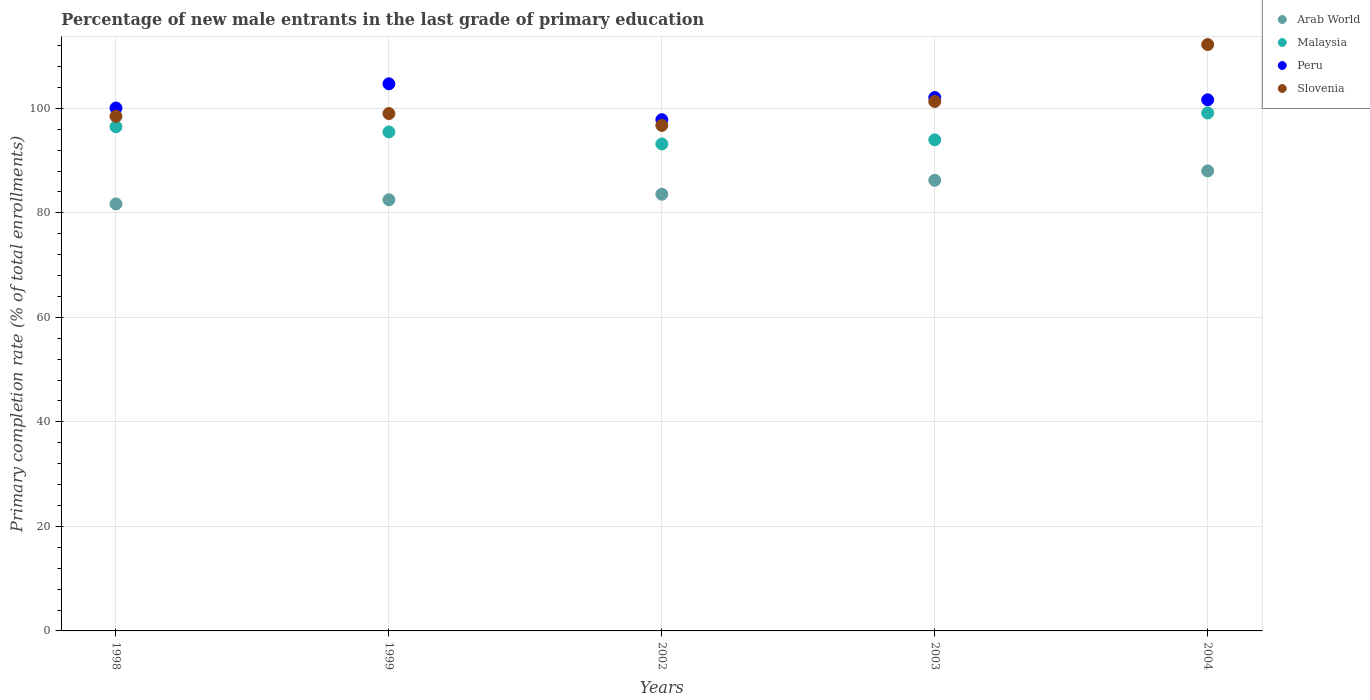How many different coloured dotlines are there?
Provide a succinct answer. 4. Is the number of dotlines equal to the number of legend labels?
Your answer should be compact. Yes. What is the percentage of new male entrants in Arab World in 2003?
Your answer should be very brief. 86.23. Across all years, what is the maximum percentage of new male entrants in Slovenia?
Offer a terse response. 112.21. Across all years, what is the minimum percentage of new male entrants in Arab World?
Your response must be concise. 81.72. In which year was the percentage of new male entrants in Malaysia minimum?
Your answer should be compact. 2002. What is the total percentage of new male entrants in Malaysia in the graph?
Keep it short and to the point. 478.25. What is the difference between the percentage of new male entrants in Malaysia in 1998 and that in 2003?
Your response must be concise. 2.5. What is the difference between the percentage of new male entrants in Malaysia in 1998 and the percentage of new male entrants in Peru in 1999?
Ensure brevity in your answer.  -8.22. What is the average percentage of new male entrants in Arab World per year?
Provide a short and direct response. 84.41. In the year 2004, what is the difference between the percentage of new male entrants in Arab World and percentage of new male entrants in Peru?
Offer a very short reply. -13.61. What is the ratio of the percentage of new male entrants in Malaysia in 1998 to that in 2002?
Offer a very short reply. 1.04. What is the difference between the highest and the second highest percentage of new male entrants in Malaysia?
Your answer should be very brief. 2.63. What is the difference between the highest and the lowest percentage of new male entrants in Arab World?
Keep it short and to the point. 6.31. In how many years, is the percentage of new male entrants in Malaysia greater than the average percentage of new male entrants in Malaysia taken over all years?
Give a very brief answer. 2. Is it the case that in every year, the sum of the percentage of new male entrants in Malaysia and percentage of new male entrants in Peru  is greater than the sum of percentage of new male entrants in Arab World and percentage of new male entrants in Slovenia?
Give a very brief answer. No. Is it the case that in every year, the sum of the percentage of new male entrants in Peru and percentage of new male entrants in Arab World  is greater than the percentage of new male entrants in Malaysia?
Ensure brevity in your answer.  Yes. Is the percentage of new male entrants in Malaysia strictly greater than the percentage of new male entrants in Slovenia over the years?
Ensure brevity in your answer.  No. What is the difference between two consecutive major ticks on the Y-axis?
Make the answer very short. 20. Are the values on the major ticks of Y-axis written in scientific E-notation?
Offer a very short reply. No. Does the graph contain any zero values?
Your answer should be very brief. No. Does the graph contain grids?
Offer a very short reply. Yes. How many legend labels are there?
Provide a succinct answer. 4. What is the title of the graph?
Keep it short and to the point. Percentage of new male entrants in the last grade of primary education. Does "India" appear as one of the legend labels in the graph?
Provide a short and direct response. No. What is the label or title of the Y-axis?
Keep it short and to the point. Primary completion rate (% of total enrollments). What is the Primary completion rate (% of total enrollments) in Arab World in 1998?
Keep it short and to the point. 81.72. What is the Primary completion rate (% of total enrollments) of Malaysia in 1998?
Offer a very short reply. 96.48. What is the Primary completion rate (% of total enrollments) of Peru in 1998?
Give a very brief answer. 100.07. What is the Primary completion rate (% of total enrollments) in Slovenia in 1998?
Ensure brevity in your answer.  98.48. What is the Primary completion rate (% of total enrollments) of Arab World in 1999?
Provide a short and direct response. 82.51. What is the Primary completion rate (% of total enrollments) in Malaysia in 1999?
Offer a very short reply. 95.49. What is the Primary completion rate (% of total enrollments) of Peru in 1999?
Offer a very short reply. 104.7. What is the Primary completion rate (% of total enrollments) of Slovenia in 1999?
Provide a succinct answer. 99.01. What is the Primary completion rate (% of total enrollments) of Arab World in 2002?
Make the answer very short. 83.57. What is the Primary completion rate (% of total enrollments) of Malaysia in 2002?
Provide a succinct answer. 93.19. What is the Primary completion rate (% of total enrollments) of Peru in 2002?
Give a very brief answer. 97.83. What is the Primary completion rate (% of total enrollments) in Slovenia in 2002?
Keep it short and to the point. 96.74. What is the Primary completion rate (% of total enrollments) of Arab World in 2003?
Provide a short and direct response. 86.23. What is the Primary completion rate (% of total enrollments) of Malaysia in 2003?
Ensure brevity in your answer.  93.98. What is the Primary completion rate (% of total enrollments) in Peru in 2003?
Your answer should be very brief. 102.07. What is the Primary completion rate (% of total enrollments) of Slovenia in 2003?
Provide a short and direct response. 101.32. What is the Primary completion rate (% of total enrollments) of Arab World in 2004?
Provide a succinct answer. 88.03. What is the Primary completion rate (% of total enrollments) in Malaysia in 2004?
Provide a succinct answer. 99.11. What is the Primary completion rate (% of total enrollments) of Peru in 2004?
Offer a terse response. 101.64. What is the Primary completion rate (% of total enrollments) in Slovenia in 2004?
Provide a succinct answer. 112.21. Across all years, what is the maximum Primary completion rate (% of total enrollments) of Arab World?
Keep it short and to the point. 88.03. Across all years, what is the maximum Primary completion rate (% of total enrollments) in Malaysia?
Make the answer very short. 99.11. Across all years, what is the maximum Primary completion rate (% of total enrollments) in Peru?
Provide a succinct answer. 104.7. Across all years, what is the maximum Primary completion rate (% of total enrollments) of Slovenia?
Your answer should be compact. 112.21. Across all years, what is the minimum Primary completion rate (% of total enrollments) of Arab World?
Offer a terse response. 81.72. Across all years, what is the minimum Primary completion rate (% of total enrollments) of Malaysia?
Your response must be concise. 93.19. Across all years, what is the minimum Primary completion rate (% of total enrollments) in Peru?
Offer a very short reply. 97.83. Across all years, what is the minimum Primary completion rate (% of total enrollments) of Slovenia?
Offer a terse response. 96.74. What is the total Primary completion rate (% of total enrollments) in Arab World in the graph?
Provide a succinct answer. 422.05. What is the total Primary completion rate (% of total enrollments) in Malaysia in the graph?
Your answer should be compact. 478.25. What is the total Primary completion rate (% of total enrollments) of Peru in the graph?
Offer a terse response. 506.32. What is the total Primary completion rate (% of total enrollments) of Slovenia in the graph?
Give a very brief answer. 507.76. What is the difference between the Primary completion rate (% of total enrollments) of Arab World in 1998 and that in 1999?
Your answer should be compact. -0.79. What is the difference between the Primary completion rate (% of total enrollments) in Peru in 1998 and that in 1999?
Your answer should be compact. -4.63. What is the difference between the Primary completion rate (% of total enrollments) in Slovenia in 1998 and that in 1999?
Make the answer very short. -0.53. What is the difference between the Primary completion rate (% of total enrollments) in Arab World in 1998 and that in 2002?
Provide a short and direct response. -1.85. What is the difference between the Primary completion rate (% of total enrollments) in Malaysia in 1998 and that in 2002?
Your answer should be compact. 3.29. What is the difference between the Primary completion rate (% of total enrollments) of Peru in 1998 and that in 2002?
Give a very brief answer. 2.24. What is the difference between the Primary completion rate (% of total enrollments) in Slovenia in 1998 and that in 2002?
Provide a short and direct response. 1.73. What is the difference between the Primary completion rate (% of total enrollments) in Arab World in 1998 and that in 2003?
Provide a short and direct response. -4.52. What is the difference between the Primary completion rate (% of total enrollments) of Malaysia in 1998 and that in 2003?
Offer a very short reply. 2.5. What is the difference between the Primary completion rate (% of total enrollments) in Peru in 1998 and that in 2003?
Provide a succinct answer. -2. What is the difference between the Primary completion rate (% of total enrollments) of Slovenia in 1998 and that in 2003?
Give a very brief answer. -2.84. What is the difference between the Primary completion rate (% of total enrollments) of Arab World in 1998 and that in 2004?
Keep it short and to the point. -6.31. What is the difference between the Primary completion rate (% of total enrollments) in Malaysia in 1998 and that in 2004?
Your answer should be very brief. -2.63. What is the difference between the Primary completion rate (% of total enrollments) of Peru in 1998 and that in 2004?
Ensure brevity in your answer.  -1.57. What is the difference between the Primary completion rate (% of total enrollments) of Slovenia in 1998 and that in 2004?
Your answer should be compact. -13.74. What is the difference between the Primary completion rate (% of total enrollments) of Arab World in 1999 and that in 2002?
Offer a very short reply. -1.06. What is the difference between the Primary completion rate (% of total enrollments) of Malaysia in 1999 and that in 2002?
Give a very brief answer. 2.3. What is the difference between the Primary completion rate (% of total enrollments) in Peru in 1999 and that in 2002?
Offer a very short reply. 6.87. What is the difference between the Primary completion rate (% of total enrollments) in Slovenia in 1999 and that in 2002?
Provide a short and direct response. 2.27. What is the difference between the Primary completion rate (% of total enrollments) in Arab World in 1999 and that in 2003?
Make the answer very short. -3.73. What is the difference between the Primary completion rate (% of total enrollments) of Malaysia in 1999 and that in 2003?
Give a very brief answer. 1.5. What is the difference between the Primary completion rate (% of total enrollments) of Peru in 1999 and that in 2003?
Your answer should be compact. 2.62. What is the difference between the Primary completion rate (% of total enrollments) of Slovenia in 1999 and that in 2003?
Offer a terse response. -2.31. What is the difference between the Primary completion rate (% of total enrollments) of Arab World in 1999 and that in 2004?
Make the answer very short. -5.52. What is the difference between the Primary completion rate (% of total enrollments) of Malaysia in 1999 and that in 2004?
Your response must be concise. -3.62. What is the difference between the Primary completion rate (% of total enrollments) of Peru in 1999 and that in 2004?
Give a very brief answer. 3.06. What is the difference between the Primary completion rate (% of total enrollments) in Slovenia in 1999 and that in 2004?
Offer a very short reply. -13.2. What is the difference between the Primary completion rate (% of total enrollments) of Arab World in 2002 and that in 2003?
Your response must be concise. -2.67. What is the difference between the Primary completion rate (% of total enrollments) of Malaysia in 2002 and that in 2003?
Make the answer very short. -0.79. What is the difference between the Primary completion rate (% of total enrollments) in Peru in 2002 and that in 2003?
Give a very brief answer. -4.24. What is the difference between the Primary completion rate (% of total enrollments) of Slovenia in 2002 and that in 2003?
Your answer should be very brief. -4.58. What is the difference between the Primary completion rate (% of total enrollments) in Arab World in 2002 and that in 2004?
Provide a short and direct response. -4.46. What is the difference between the Primary completion rate (% of total enrollments) of Malaysia in 2002 and that in 2004?
Your answer should be compact. -5.92. What is the difference between the Primary completion rate (% of total enrollments) in Peru in 2002 and that in 2004?
Provide a short and direct response. -3.81. What is the difference between the Primary completion rate (% of total enrollments) in Slovenia in 2002 and that in 2004?
Your answer should be compact. -15.47. What is the difference between the Primary completion rate (% of total enrollments) in Arab World in 2003 and that in 2004?
Your answer should be very brief. -1.8. What is the difference between the Primary completion rate (% of total enrollments) in Malaysia in 2003 and that in 2004?
Your answer should be compact. -5.13. What is the difference between the Primary completion rate (% of total enrollments) in Peru in 2003 and that in 2004?
Provide a short and direct response. 0.44. What is the difference between the Primary completion rate (% of total enrollments) in Slovenia in 2003 and that in 2004?
Provide a succinct answer. -10.89. What is the difference between the Primary completion rate (% of total enrollments) in Arab World in 1998 and the Primary completion rate (% of total enrollments) in Malaysia in 1999?
Your answer should be compact. -13.77. What is the difference between the Primary completion rate (% of total enrollments) in Arab World in 1998 and the Primary completion rate (% of total enrollments) in Peru in 1999?
Offer a very short reply. -22.98. What is the difference between the Primary completion rate (% of total enrollments) in Arab World in 1998 and the Primary completion rate (% of total enrollments) in Slovenia in 1999?
Give a very brief answer. -17.29. What is the difference between the Primary completion rate (% of total enrollments) in Malaysia in 1998 and the Primary completion rate (% of total enrollments) in Peru in 1999?
Make the answer very short. -8.22. What is the difference between the Primary completion rate (% of total enrollments) in Malaysia in 1998 and the Primary completion rate (% of total enrollments) in Slovenia in 1999?
Provide a short and direct response. -2.53. What is the difference between the Primary completion rate (% of total enrollments) in Peru in 1998 and the Primary completion rate (% of total enrollments) in Slovenia in 1999?
Ensure brevity in your answer.  1.06. What is the difference between the Primary completion rate (% of total enrollments) in Arab World in 1998 and the Primary completion rate (% of total enrollments) in Malaysia in 2002?
Provide a succinct answer. -11.47. What is the difference between the Primary completion rate (% of total enrollments) of Arab World in 1998 and the Primary completion rate (% of total enrollments) of Peru in 2002?
Give a very brief answer. -16.12. What is the difference between the Primary completion rate (% of total enrollments) of Arab World in 1998 and the Primary completion rate (% of total enrollments) of Slovenia in 2002?
Offer a very short reply. -15.03. What is the difference between the Primary completion rate (% of total enrollments) of Malaysia in 1998 and the Primary completion rate (% of total enrollments) of Peru in 2002?
Offer a very short reply. -1.35. What is the difference between the Primary completion rate (% of total enrollments) of Malaysia in 1998 and the Primary completion rate (% of total enrollments) of Slovenia in 2002?
Make the answer very short. -0.26. What is the difference between the Primary completion rate (% of total enrollments) in Peru in 1998 and the Primary completion rate (% of total enrollments) in Slovenia in 2002?
Offer a very short reply. 3.33. What is the difference between the Primary completion rate (% of total enrollments) in Arab World in 1998 and the Primary completion rate (% of total enrollments) in Malaysia in 2003?
Give a very brief answer. -12.27. What is the difference between the Primary completion rate (% of total enrollments) of Arab World in 1998 and the Primary completion rate (% of total enrollments) of Peru in 2003?
Provide a short and direct response. -20.36. What is the difference between the Primary completion rate (% of total enrollments) of Arab World in 1998 and the Primary completion rate (% of total enrollments) of Slovenia in 2003?
Provide a succinct answer. -19.6. What is the difference between the Primary completion rate (% of total enrollments) of Malaysia in 1998 and the Primary completion rate (% of total enrollments) of Peru in 2003?
Ensure brevity in your answer.  -5.6. What is the difference between the Primary completion rate (% of total enrollments) of Malaysia in 1998 and the Primary completion rate (% of total enrollments) of Slovenia in 2003?
Offer a terse response. -4.84. What is the difference between the Primary completion rate (% of total enrollments) of Peru in 1998 and the Primary completion rate (% of total enrollments) of Slovenia in 2003?
Your answer should be very brief. -1.25. What is the difference between the Primary completion rate (% of total enrollments) of Arab World in 1998 and the Primary completion rate (% of total enrollments) of Malaysia in 2004?
Keep it short and to the point. -17.4. What is the difference between the Primary completion rate (% of total enrollments) of Arab World in 1998 and the Primary completion rate (% of total enrollments) of Peru in 2004?
Your response must be concise. -19.92. What is the difference between the Primary completion rate (% of total enrollments) in Arab World in 1998 and the Primary completion rate (% of total enrollments) in Slovenia in 2004?
Offer a very short reply. -30.5. What is the difference between the Primary completion rate (% of total enrollments) in Malaysia in 1998 and the Primary completion rate (% of total enrollments) in Peru in 2004?
Ensure brevity in your answer.  -5.16. What is the difference between the Primary completion rate (% of total enrollments) in Malaysia in 1998 and the Primary completion rate (% of total enrollments) in Slovenia in 2004?
Your response must be concise. -15.73. What is the difference between the Primary completion rate (% of total enrollments) in Peru in 1998 and the Primary completion rate (% of total enrollments) in Slovenia in 2004?
Ensure brevity in your answer.  -12.14. What is the difference between the Primary completion rate (% of total enrollments) in Arab World in 1999 and the Primary completion rate (% of total enrollments) in Malaysia in 2002?
Offer a very short reply. -10.68. What is the difference between the Primary completion rate (% of total enrollments) of Arab World in 1999 and the Primary completion rate (% of total enrollments) of Peru in 2002?
Offer a terse response. -15.33. What is the difference between the Primary completion rate (% of total enrollments) of Arab World in 1999 and the Primary completion rate (% of total enrollments) of Slovenia in 2002?
Make the answer very short. -14.24. What is the difference between the Primary completion rate (% of total enrollments) in Malaysia in 1999 and the Primary completion rate (% of total enrollments) in Peru in 2002?
Provide a short and direct response. -2.34. What is the difference between the Primary completion rate (% of total enrollments) in Malaysia in 1999 and the Primary completion rate (% of total enrollments) in Slovenia in 2002?
Offer a terse response. -1.25. What is the difference between the Primary completion rate (% of total enrollments) of Peru in 1999 and the Primary completion rate (% of total enrollments) of Slovenia in 2002?
Give a very brief answer. 7.96. What is the difference between the Primary completion rate (% of total enrollments) in Arab World in 1999 and the Primary completion rate (% of total enrollments) in Malaysia in 2003?
Offer a very short reply. -11.48. What is the difference between the Primary completion rate (% of total enrollments) of Arab World in 1999 and the Primary completion rate (% of total enrollments) of Peru in 2003?
Keep it short and to the point. -19.57. What is the difference between the Primary completion rate (% of total enrollments) in Arab World in 1999 and the Primary completion rate (% of total enrollments) in Slovenia in 2003?
Make the answer very short. -18.81. What is the difference between the Primary completion rate (% of total enrollments) in Malaysia in 1999 and the Primary completion rate (% of total enrollments) in Peru in 2003?
Provide a succinct answer. -6.59. What is the difference between the Primary completion rate (% of total enrollments) in Malaysia in 1999 and the Primary completion rate (% of total enrollments) in Slovenia in 2003?
Provide a short and direct response. -5.83. What is the difference between the Primary completion rate (% of total enrollments) in Peru in 1999 and the Primary completion rate (% of total enrollments) in Slovenia in 2003?
Provide a short and direct response. 3.38. What is the difference between the Primary completion rate (% of total enrollments) in Arab World in 1999 and the Primary completion rate (% of total enrollments) in Malaysia in 2004?
Provide a short and direct response. -16.61. What is the difference between the Primary completion rate (% of total enrollments) of Arab World in 1999 and the Primary completion rate (% of total enrollments) of Peru in 2004?
Your answer should be very brief. -19.13. What is the difference between the Primary completion rate (% of total enrollments) in Arab World in 1999 and the Primary completion rate (% of total enrollments) in Slovenia in 2004?
Your answer should be compact. -29.71. What is the difference between the Primary completion rate (% of total enrollments) of Malaysia in 1999 and the Primary completion rate (% of total enrollments) of Peru in 2004?
Keep it short and to the point. -6.15. What is the difference between the Primary completion rate (% of total enrollments) in Malaysia in 1999 and the Primary completion rate (% of total enrollments) in Slovenia in 2004?
Offer a very short reply. -16.72. What is the difference between the Primary completion rate (% of total enrollments) in Peru in 1999 and the Primary completion rate (% of total enrollments) in Slovenia in 2004?
Your response must be concise. -7.51. What is the difference between the Primary completion rate (% of total enrollments) of Arab World in 2002 and the Primary completion rate (% of total enrollments) of Malaysia in 2003?
Offer a very short reply. -10.42. What is the difference between the Primary completion rate (% of total enrollments) in Arab World in 2002 and the Primary completion rate (% of total enrollments) in Peru in 2003?
Your response must be concise. -18.51. What is the difference between the Primary completion rate (% of total enrollments) of Arab World in 2002 and the Primary completion rate (% of total enrollments) of Slovenia in 2003?
Offer a very short reply. -17.75. What is the difference between the Primary completion rate (% of total enrollments) of Malaysia in 2002 and the Primary completion rate (% of total enrollments) of Peru in 2003?
Provide a succinct answer. -8.89. What is the difference between the Primary completion rate (% of total enrollments) in Malaysia in 2002 and the Primary completion rate (% of total enrollments) in Slovenia in 2003?
Your response must be concise. -8.13. What is the difference between the Primary completion rate (% of total enrollments) of Peru in 2002 and the Primary completion rate (% of total enrollments) of Slovenia in 2003?
Offer a very short reply. -3.49. What is the difference between the Primary completion rate (% of total enrollments) of Arab World in 2002 and the Primary completion rate (% of total enrollments) of Malaysia in 2004?
Make the answer very short. -15.55. What is the difference between the Primary completion rate (% of total enrollments) of Arab World in 2002 and the Primary completion rate (% of total enrollments) of Peru in 2004?
Offer a very short reply. -18.07. What is the difference between the Primary completion rate (% of total enrollments) of Arab World in 2002 and the Primary completion rate (% of total enrollments) of Slovenia in 2004?
Keep it short and to the point. -28.65. What is the difference between the Primary completion rate (% of total enrollments) in Malaysia in 2002 and the Primary completion rate (% of total enrollments) in Peru in 2004?
Keep it short and to the point. -8.45. What is the difference between the Primary completion rate (% of total enrollments) of Malaysia in 2002 and the Primary completion rate (% of total enrollments) of Slovenia in 2004?
Offer a terse response. -19.02. What is the difference between the Primary completion rate (% of total enrollments) in Peru in 2002 and the Primary completion rate (% of total enrollments) in Slovenia in 2004?
Your answer should be compact. -14.38. What is the difference between the Primary completion rate (% of total enrollments) of Arab World in 2003 and the Primary completion rate (% of total enrollments) of Malaysia in 2004?
Your answer should be very brief. -12.88. What is the difference between the Primary completion rate (% of total enrollments) in Arab World in 2003 and the Primary completion rate (% of total enrollments) in Peru in 2004?
Give a very brief answer. -15.41. What is the difference between the Primary completion rate (% of total enrollments) in Arab World in 2003 and the Primary completion rate (% of total enrollments) in Slovenia in 2004?
Offer a very short reply. -25.98. What is the difference between the Primary completion rate (% of total enrollments) of Malaysia in 2003 and the Primary completion rate (% of total enrollments) of Peru in 2004?
Make the answer very short. -7.66. What is the difference between the Primary completion rate (% of total enrollments) in Malaysia in 2003 and the Primary completion rate (% of total enrollments) in Slovenia in 2004?
Your answer should be very brief. -18.23. What is the difference between the Primary completion rate (% of total enrollments) in Peru in 2003 and the Primary completion rate (% of total enrollments) in Slovenia in 2004?
Give a very brief answer. -10.14. What is the average Primary completion rate (% of total enrollments) of Arab World per year?
Offer a terse response. 84.41. What is the average Primary completion rate (% of total enrollments) of Malaysia per year?
Offer a terse response. 95.65. What is the average Primary completion rate (% of total enrollments) of Peru per year?
Your answer should be very brief. 101.26. What is the average Primary completion rate (% of total enrollments) in Slovenia per year?
Provide a succinct answer. 101.55. In the year 1998, what is the difference between the Primary completion rate (% of total enrollments) of Arab World and Primary completion rate (% of total enrollments) of Malaysia?
Offer a very short reply. -14.76. In the year 1998, what is the difference between the Primary completion rate (% of total enrollments) in Arab World and Primary completion rate (% of total enrollments) in Peru?
Offer a terse response. -18.36. In the year 1998, what is the difference between the Primary completion rate (% of total enrollments) in Arab World and Primary completion rate (% of total enrollments) in Slovenia?
Provide a succinct answer. -16.76. In the year 1998, what is the difference between the Primary completion rate (% of total enrollments) in Malaysia and Primary completion rate (% of total enrollments) in Peru?
Provide a succinct answer. -3.59. In the year 1998, what is the difference between the Primary completion rate (% of total enrollments) of Malaysia and Primary completion rate (% of total enrollments) of Slovenia?
Your answer should be compact. -2. In the year 1998, what is the difference between the Primary completion rate (% of total enrollments) of Peru and Primary completion rate (% of total enrollments) of Slovenia?
Keep it short and to the point. 1.6. In the year 1999, what is the difference between the Primary completion rate (% of total enrollments) in Arab World and Primary completion rate (% of total enrollments) in Malaysia?
Ensure brevity in your answer.  -12.98. In the year 1999, what is the difference between the Primary completion rate (% of total enrollments) of Arab World and Primary completion rate (% of total enrollments) of Peru?
Offer a very short reply. -22.19. In the year 1999, what is the difference between the Primary completion rate (% of total enrollments) in Arab World and Primary completion rate (% of total enrollments) in Slovenia?
Give a very brief answer. -16.5. In the year 1999, what is the difference between the Primary completion rate (% of total enrollments) in Malaysia and Primary completion rate (% of total enrollments) in Peru?
Provide a short and direct response. -9.21. In the year 1999, what is the difference between the Primary completion rate (% of total enrollments) of Malaysia and Primary completion rate (% of total enrollments) of Slovenia?
Give a very brief answer. -3.52. In the year 1999, what is the difference between the Primary completion rate (% of total enrollments) in Peru and Primary completion rate (% of total enrollments) in Slovenia?
Ensure brevity in your answer.  5.69. In the year 2002, what is the difference between the Primary completion rate (% of total enrollments) of Arab World and Primary completion rate (% of total enrollments) of Malaysia?
Give a very brief answer. -9.62. In the year 2002, what is the difference between the Primary completion rate (% of total enrollments) in Arab World and Primary completion rate (% of total enrollments) in Peru?
Make the answer very short. -14.27. In the year 2002, what is the difference between the Primary completion rate (% of total enrollments) of Arab World and Primary completion rate (% of total enrollments) of Slovenia?
Make the answer very short. -13.18. In the year 2002, what is the difference between the Primary completion rate (% of total enrollments) in Malaysia and Primary completion rate (% of total enrollments) in Peru?
Make the answer very short. -4.64. In the year 2002, what is the difference between the Primary completion rate (% of total enrollments) of Malaysia and Primary completion rate (% of total enrollments) of Slovenia?
Your answer should be compact. -3.55. In the year 2002, what is the difference between the Primary completion rate (% of total enrollments) in Peru and Primary completion rate (% of total enrollments) in Slovenia?
Your answer should be very brief. 1.09. In the year 2003, what is the difference between the Primary completion rate (% of total enrollments) in Arab World and Primary completion rate (% of total enrollments) in Malaysia?
Make the answer very short. -7.75. In the year 2003, what is the difference between the Primary completion rate (% of total enrollments) in Arab World and Primary completion rate (% of total enrollments) in Peru?
Ensure brevity in your answer.  -15.84. In the year 2003, what is the difference between the Primary completion rate (% of total enrollments) in Arab World and Primary completion rate (% of total enrollments) in Slovenia?
Ensure brevity in your answer.  -15.09. In the year 2003, what is the difference between the Primary completion rate (% of total enrollments) in Malaysia and Primary completion rate (% of total enrollments) in Peru?
Your response must be concise. -8.09. In the year 2003, what is the difference between the Primary completion rate (% of total enrollments) in Malaysia and Primary completion rate (% of total enrollments) in Slovenia?
Your answer should be compact. -7.34. In the year 2003, what is the difference between the Primary completion rate (% of total enrollments) of Peru and Primary completion rate (% of total enrollments) of Slovenia?
Provide a short and direct response. 0.76. In the year 2004, what is the difference between the Primary completion rate (% of total enrollments) of Arab World and Primary completion rate (% of total enrollments) of Malaysia?
Ensure brevity in your answer.  -11.08. In the year 2004, what is the difference between the Primary completion rate (% of total enrollments) in Arab World and Primary completion rate (% of total enrollments) in Peru?
Offer a very short reply. -13.61. In the year 2004, what is the difference between the Primary completion rate (% of total enrollments) of Arab World and Primary completion rate (% of total enrollments) of Slovenia?
Offer a terse response. -24.18. In the year 2004, what is the difference between the Primary completion rate (% of total enrollments) in Malaysia and Primary completion rate (% of total enrollments) in Peru?
Your response must be concise. -2.53. In the year 2004, what is the difference between the Primary completion rate (% of total enrollments) of Malaysia and Primary completion rate (% of total enrollments) of Slovenia?
Make the answer very short. -13.1. In the year 2004, what is the difference between the Primary completion rate (% of total enrollments) of Peru and Primary completion rate (% of total enrollments) of Slovenia?
Keep it short and to the point. -10.57. What is the ratio of the Primary completion rate (% of total enrollments) in Malaysia in 1998 to that in 1999?
Your answer should be very brief. 1.01. What is the ratio of the Primary completion rate (% of total enrollments) in Peru in 1998 to that in 1999?
Your answer should be compact. 0.96. What is the ratio of the Primary completion rate (% of total enrollments) of Arab World in 1998 to that in 2002?
Offer a terse response. 0.98. What is the ratio of the Primary completion rate (% of total enrollments) of Malaysia in 1998 to that in 2002?
Give a very brief answer. 1.04. What is the ratio of the Primary completion rate (% of total enrollments) in Peru in 1998 to that in 2002?
Offer a terse response. 1.02. What is the ratio of the Primary completion rate (% of total enrollments) in Slovenia in 1998 to that in 2002?
Provide a succinct answer. 1.02. What is the ratio of the Primary completion rate (% of total enrollments) of Arab World in 1998 to that in 2003?
Give a very brief answer. 0.95. What is the ratio of the Primary completion rate (% of total enrollments) in Malaysia in 1998 to that in 2003?
Provide a short and direct response. 1.03. What is the ratio of the Primary completion rate (% of total enrollments) of Peru in 1998 to that in 2003?
Your response must be concise. 0.98. What is the ratio of the Primary completion rate (% of total enrollments) of Slovenia in 1998 to that in 2003?
Offer a very short reply. 0.97. What is the ratio of the Primary completion rate (% of total enrollments) of Arab World in 1998 to that in 2004?
Offer a terse response. 0.93. What is the ratio of the Primary completion rate (% of total enrollments) in Malaysia in 1998 to that in 2004?
Provide a succinct answer. 0.97. What is the ratio of the Primary completion rate (% of total enrollments) in Peru in 1998 to that in 2004?
Keep it short and to the point. 0.98. What is the ratio of the Primary completion rate (% of total enrollments) of Slovenia in 1998 to that in 2004?
Give a very brief answer. 0.88. What is the ratio of the Primary completion rate (% of total enrollments) in Arab World in 1999 to that in 2002?
Ensure brevity in your answer.  0.99. What is the ratio of the Primary completion rate (% of total enrollments) of Malaysia in 1999 to that in 2002?
Your answer should be very brief. 1.02. What is the ratio of the Primary completion rate (% of total enrollments) of Peru in 1999 to that in 2002?
Give a very brief answer. 1.07. What is the ratio of the Primary completion rate (% of total enrollments) of Slovenia in 1999 to that in 2002?
Provide a succinct answer. 1.02. What is the ratio of the Primary completion rate (% of total enrollments) in Arab World in 1999 to that in 2003?
Ensure brevity in your answer.  0.96. What is the ratio of the Primary completion rate (% of total enrollments) of Peru in 1999 to that in 2003?
Offer a terse response. 1.03. What is the ratio of the Primary completion rate (% of total enrollments) in Slovenia in 1999 to that in 2003?
Give a very brief answer. 0.98. What is the ratio of the Primary completion rate (% of total enrollments) of Arab World in 1999 to that in 2004?
Give a very brief answer. 0.94. What is the ratio of the Primary completion rate (% of total enrollments) of Malaysia in 1999 to that in 2004?
Make the answer very short. 0.96. What is the ratio of the Primary completion rate (% of total enrollments) in Peru in 1999 to that in 2004?
Ensure brevity in your answer.  1.03. What is the ratio of the Primary completion rate (% of total enrollments) of Slovenia in 1999 to that in 2004?
Make the answer very short. 0.88. What is the ratio of the Primary completion rate (% of total enrollments) in Arab World in 2002 to that in 2003?
Give a very brief answer. 0.97. What is the ratio of the Primary completion rate (% of total enrollments) of Malaysia in 2002 to that in 2003?
Ensure brevity in your answer.  0.99. What is the ratio of the Primary completion rate (% of total enrollments) of Peru in 2002 to that in 2003?
Your response must be concise. 0.96. What is the ratio of the Primary completion rate (% of total enrollments) in Slovenia in 2002 to that in 2003?
Your response must be concise. 0.95. What is the ratio of the Primary completion rate (% of total enrollments) of Arab World in 2002 to that in 2004?
Provide a short and direct response. 0.95. What is the ratio of the Primary completion rate (% of total enrollments) in Malaysia in 2002 to that in 2004?
Provide a short and direct response. 0.94. What is the ratio of the Primary completion rate (% of total enrollments) in Peru in 2002 to that in 2004?
Your answer should be compact. 0.96. What is the ratio of the Primary completion rate (% of total enrollments) in Slovenia in 2002 to that in 2004?
Ensure brevity in your answer.  0.86. What is the ratio of the Primary completion rate (% of total enrollments) of Arab World in 2003 to that in 2004?
Your response must be concise. 0.98. What is the ratio of the Primary completion rate (% of total enrollments) in Malaysia in 2003 to that in 2004?
Your answer should be very brief. 0.95. What is the ratio of the Primary completion rate (% of total enrollments) of Slovenia in 2003 to that in 2004?
Ensure brevity in your answer.  0.9. What is the difference between the highest and the second highest Primary completion rate (% of total enrollments) of Arab World?
Your response must be concise. 1.8. What is the difference between the highest and the second highest Primary completion rate (% of total enrollments) of Malaysia?
Provide a short and direct response. 2.63. What is the difference between the highest and the second highest Primary completion rate (% of total enrollments) in Peru?
Give a very brief answer. 2.62. What is the difference between the highest and the second highest Primary completion rate (% of total enrollments) in Slovenia?
Offer a terse response. 10.89. What is the difference between the highest and the lowest Primary completion rate (% of total enrollments) of Arab World?
Provide a short and direct response. 6.31. What is the difference between the highest and the lowest Primary completion rate (% of total enrollments) of Malaysia?
Your answer should be very brief. 5.92. What is the difference between the highest and the lowest Primary completion rate (% of total enrollments) of Peru?
Offer a very short reply. 6.87. What is the difference between the highest and the lowest Primary completion rate (% of total enrollments) of Slovenia?
Make the answer very short. 15.47. 